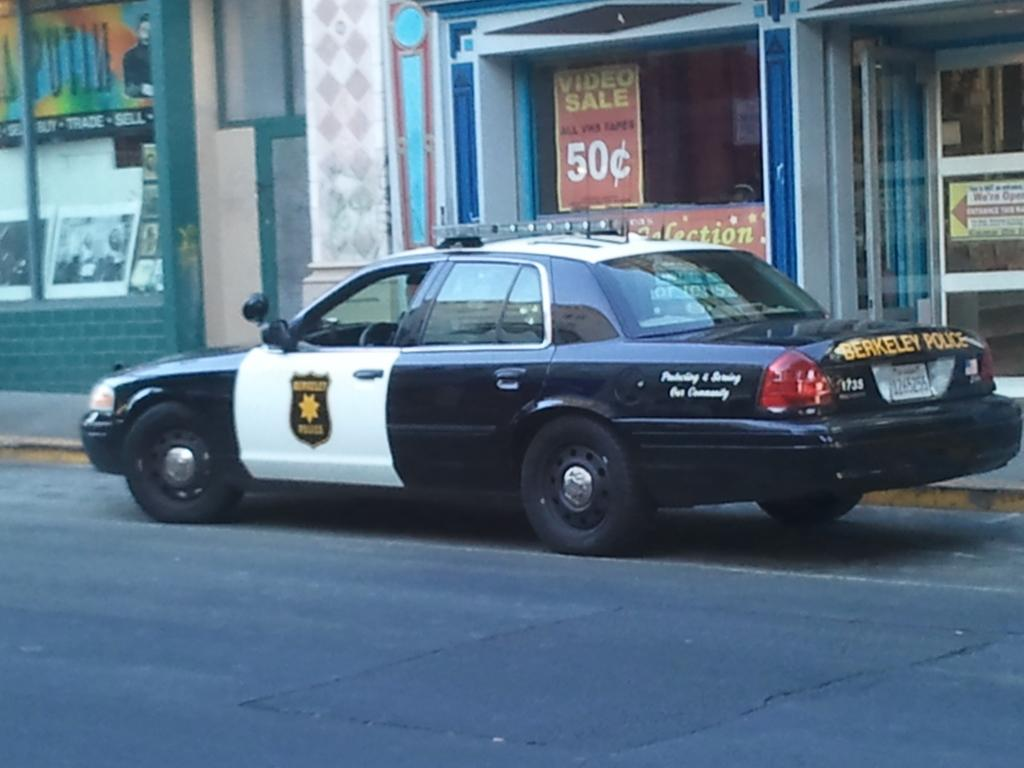<image>
Summarize the visual content of the image. A Berkeley Police car is parked on the street. 